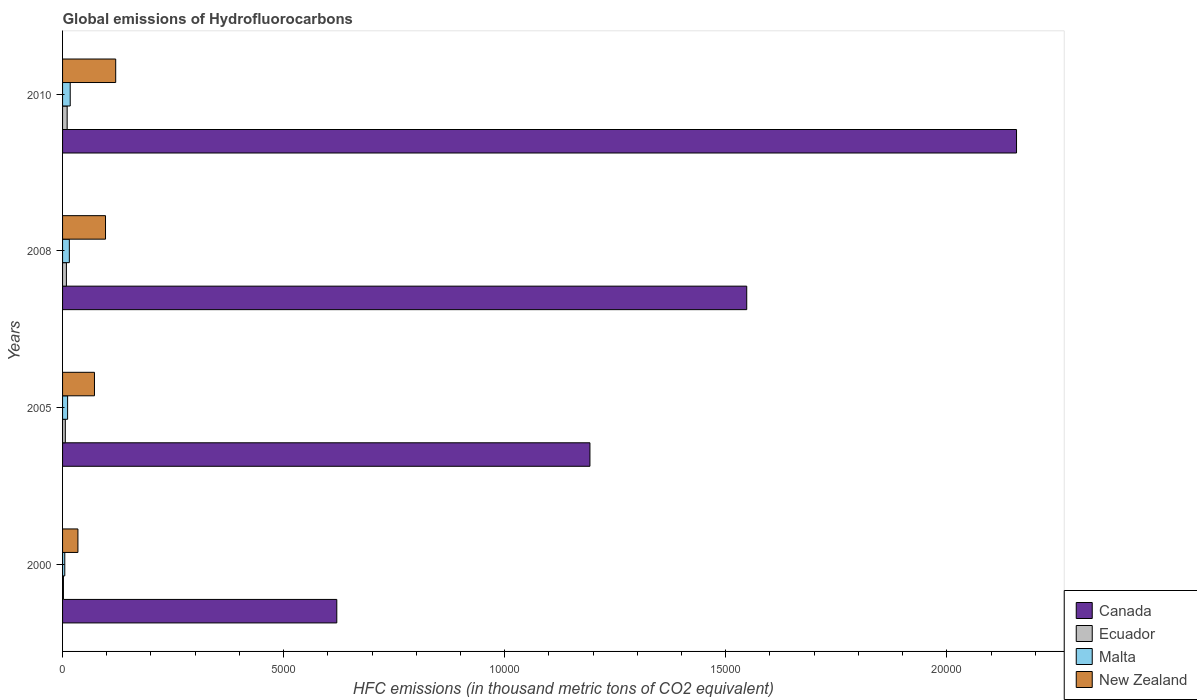How many groups of bars are there?
Offer a very short reply. 4. Are the number of bars on each tick of the Y-axis equal?
Your answer should be compact. Yes. How many bars are there on the 3rd tick from the top?
Ensure brevity in your answer.  4. What is the label of the 2nd group of bars from the top?
Ensure brevity in your answer.  2008. In how many cases, is the number of bars for a given year not equal to the number of legend labels?
Provide a succinct answer. 0. Across all years, what is the maximum global emissions of Hydrofluorocarbons in Ecuador?
Your response must be concise. 104. Across all years, what is the minimum global emissions of Hydrofluorocarbons in Malta?
Your answer should be very brief. 50. In which year was the global emissions of Hydrofluorocarbons in Canada maximum?
Make the answer very short. 2010. In which year was the global emissions of Hydrofluorocarbons in New Zealand minimum?
Provide a succinct answer. 2000. What is the total global emissions of Hydrofluorocarbons in Malta in the graph?
Your response must be concise. 490.4. What is the difference between the global emissions of Hydrofluorocarbons in Malta in 2000 and that in 2005?
Offer a very short reply. -64.2. What is the difference between the global emissions of Hydrofluorocarbons in Ecuador in 2010 and the global emissions of Hydrofluorocarbons in New Zealand in 2000?
Offer a very short reply. -243.3. What is the average global emissions of Hydrofluorocarbons in Malta per year?
Provide a succinct answer. 122.6. In the year 2000, what is the difference between the global emissions of Hydrofluorocarbons in Ecuador and global emissions of Hydrofluorocarbons in New Zealand?
Give a very brief answer. -327.6. In how many years, is the global emissions of Hydrofluorocarbons in New Zealand greater than 20000 thousand metric tons?
Your answer should be compact. 0. What is the ratio of the global emissions of Hydrofluorocarbons in New Zealand in 2005 to that in 2010?
Make the answer very short. 0.6. What is the difference between the highest and the second highest global emissions of Hydrofluorocarbons in New Zealand?
Your answer should be compact. 230.6. What is the difference between the highest and the lowest global emissions of Hydrofluorocarbons in New Zealand?
Offer a terse response. 854.7. What does the 4th bar from the top in 2000 represents?
Your answer should be very brief. Canada. What does the 3rd bar from the bottom in 2010 represents?
Give a very brief answer. Malta. How many years are there in the graph?
Make the answer very short. 4. How many legend labels are there?
Your answer should be very brief. 4. How are the legend labels stacked?
Give a very brief answer. Vertical. What is the title of the graph?
Offer a very short reply. Global emissions of Hydrofluorocarbons. What is the label or title of the X-axis?
Your answer should be very brief. HFC emissions (in thousand metric tons of CO2 equivalent). What is the HFC emissions (in thousand metric tons of CO2 equivalent) of Canada in 2000?
Your answer should be compact. 6202.8. What is the HFC emissions (in thousand metric tons of CO2 equivalent) of Ecuador in 2000?
Provide a succinct answer. 19.7. What is the HFC emissions (in thousand metric tons of CO2 equivalent) of Malta in 2000?
Your response must be concise. 50. What is the HFC emissions (in thousand metric tons of CO2 equivalent) in New Zealand in 2000?
Ensure brevity in your answer.  347.3. What is the HFC emissions (in thousand metric tons of CO2 equivalent) of Canada in 2005?
Offer a very short reply. 1.19e+04. What is the HFC emissions (in thousand metric tons of CO2 equivalent) of Ecuador in 2005?
Offer a very short reply. 62.2. What is the HFC emissions (in thousand metric tons of CO2 equivalent) in Malta in 2005?
Ensure brevity in your answer.  114.2. What is the HFC emissions (in thousand metric tons of CO2 equivalent) of New Zealand in 2005?
Your answer should be compact. 721.7. What is the HFC emissions (in thousand metric tons of CO2 equivalent) of Canada in 2008?
Provide a succinct answer. 1.55e+04. What is the HFC emissions (in thousand metric tons of CO2 equivalent) in Ecuador in 2008?
Your answer should be very brief. 86.7. What is the HFC emissions (in thousand metric tons of CO2 equivalent) in Malta in 2008?
Your answer should be compact. 153.2. What is the HFC emissions (in thousand metric tons of CO2 equivalent) in New Zealand in 2008?
Your response must be concise. 971.4. What is the HFC emissions (in thousand metric tons of CO2 equivalent) in Canada in 2010?
Your response must be concise. 2.16e+04. What is the HFC emissions (in thousand metric tons of CO2 equivalent) of Ecuador in 2010?
Your response must be concise. 104. What is the HFC emissions (in thousand metric tons of CO2 equivalent) in Malta in 2010?
Your answer should be compact. 173. What is the HFC emissions (in thousand metric tons of CO2 equivalent) in New Zealand in 2010?
Provide a short and direct response. 1202. Across all years, what is the maximum HFC emissions (in thousand metric tons of CO2 equivalent) of Canada?
Keep it short and to the point. 2.16e+04. Across all years, what is the maximum HFC emissions (in thousand metric tons of CO2 equivalent) in Ecuador?
Give a very brief answer. 104. Across all years, what is the maximum HFC emissions (in thousand metric tons of CO2 equivalent) of Malta?
Make the answer very short. 173. Across all years, what is the maximum HFC emissions (in thousand metric tons of CO2 equivalent) of New Zealand?
Give a very brief answer. 1202. Across all years, what is the minimum HFC emissions (in thousand metric tons of CO2 equivalent) of Canada?
Offer a terse response. 6202.8. Across all years, what is the minimum HFC emissions (in thousand metric tons of CO2 equivalent) in Ecuador?
Offer a very short reply. 19.7. Across all years, what is the minimum HFC emissions (in thousand metric tons of CO2 equivalent) of New Zealand?
Your response must be concise. 347.3. What is the total HFC emissions (in thousand metric tons of CO2 equivalent) of Canada in the graph?
Your answer should be very brief. 5.52e+04. What is the total HFC emissions (in thousand metric tons of CO2 equivalent) of Ecuador in the graph?
Ensure brevity in your answer.  272.6. What is the total HFC emissions (in thousand metric tons of CO2 equivalent) of Malta in the graph?
Provide a short and direct response. 490.4. What is the total HFC emissions (in thousand metric tons of CO2 equivalent) in New Zealand in the graph?
Your response must be concise. 3242.4. What is the difference between the HFC emissions (in thousand metric tons of CO2 equivalent) in Canada in 2000 and that in 2005?
Offer a very short reply. -5725.6. What is the difference between the HFC emissions (in thousand metric tons of CO2 equivalent) of Ecuador in 2000 and that in 2005?
Provide a short and direct response. -42.5. What is the difference between the HFC emissions (in thousand metric tons of CO2 equivalent) of Malta in 2000 and that in 2005?
Offer a terse response. -64.2. What is the difference between the HFC emissions (in thousand metric tons of CO2 equivalent) in New Zealand in 2000 and that in 2005?
Your answer should be very brief. -374.4. What is the difference between the HFC emissions (in thousand metric tons of CO2 equivalent) of Canada in 2000 and that in 2008?
Offer a terse response. -9272. What is the difference between the HFC emissions (in thousand metric tons of CO2 equivalent) in Ecuador in 2000 and that in 2008?
Provide a succinct answer. -67. What is the difference between the HFC emissions (in thousand metric tons of CO2 equivalent) in Malta in 2000 and that in 2008?
Give a very brief answer. -103.2. What is the difference between the HFC emissions (in thousand metric tons of CO2 equivalent) in New Zealand in 2000 and that in 2008?
Give a very brief answer. -624.1. What is the difference between the HFC emissions (in thousand metric tons of CO2 equivalent) in Canada in 2000 and that in 2010?
Make the answer very short. -1.54e+04. What is the difference between the HFC emissions (in thousand metric tons of CO2 equivalent) in Ecuador in 2000 and that in 2010?
Offer a terse response. -84.3. What is the difference between the HFC emissions (in thousand metric tons of CO2 equivalent) of Malta in 2000 and that in 2010?
Give a very brief answer. -123. What is the difference between the HFC emissions (in thousand metric tons of CO2 equivalent) in New Zealand in 2000 and that in 2010?
Make the answer very short. -854.7. What is the difference between the HFC emissions (in thousand metric tons of CO2 equivalent) of Canada in 2005 and that in 2008?
Give a very brief answer. -3546.4. What is the difference between the HFC emissions (in thousand metric tons of CO2 equivalent) in Ecuador in 2005 and that in 2008?
Give a very brief answer. -24.5. What is the difference between the HFC emissions (in thousand metric tons of CO2 equivalent) of Malta in 2005 and that in 2008?
Ensure brevity in your answer.  -39. What is the difference between the HFC emissions (in thousand metric tons of CO2 equivalent) in New Zealand in 2005 and that in 2008?
Your response must be concise. -249.7. What is the difference between the HFC emissions (in thousand metric tons of CO2 equivalent) in Canada in 2005 and that in 2010?
Offer a terse response. -9648.6. What is the difference between the HFC emissions (in thousand metric tons of CO2 equivalent) in Ecuador in 2005 and that in 2010?
Provide a succinct answer. -41.8. What is the difference between the HFC emissions (in thousand metric tons of CO2 equivalent) in Malta in 2005 and that in 2010?
Ensure brevity in your answer.  -58.8. What is the difference between the HFC emissions (in thousand metric tons of CO2 equivalent) of New Zealand in 2005 and that in 2010?
Give a very brief answer. -480.3. What is the difference between the HFC emissions (in thousand metric tons of CO2 equivalent) of Canada in 2008 and that in 2010?
Your answer should be very brief. -6102.2. What is the difference between the HFC emissions (in thousand metric tons of CO2 equivalent) in Ecuador in 2008 and that in 2010?
Make the answer very short. -17.3. What is the difference between the HFC emissions (in thousand metric tons of CO2 equivalent) of Malta in 2008 and that in 2010?
Offer a very short reply. -19.8. What is the difference between the HFC emissions (in thousand metric tons of CO2 equivalent) in New Zealand in 2008 and that in 2010?
Ensure brevity in your answer.  -230.6. What is the difference between the HFC emissions (in thousand metric tons of CO2 equivalent) in Canada in 2000 and the HFC emissions (in thousand metric tons of CO2 equivalent) in Ecuador in 2005?
Keep it short and to the point. 6140.6. What is the difference between the HFC emissions (in thousand metric tons of CO2 equivalent) of Canada in 2000 and the HFC emissions (in thousand metric tons of CO2 equivalent) of Malta in 2005?
Offer a very short reply. 6088.6. What is the difference between the HFC emissions (in thousand metric tons of CO2 equivalent) of Canada in 2000 and the HFC emissions (in thousand metric tons of CO2 equivalent) of New Zealand in 2005?
Your response must be concise. 5481.1. What is the difference between the HFC emissions (in thousand metric tons of CO2 equivalent) in Ecuador in 2000 and the HFC emissions (in thousand metric tons of CO2 equivalent) in Malta in 2005?
Give a very brief answer. -94.5. What is the difference between the HFC emissions (in thousand metric tons of CO2 equivalent) of Ecuador in 2000 and the HFC emissions (in thousand metric tons of CO2 equivalent) of New Zealand in 2005?
Keep it short and to the point. -702. What is the difference between the HFC emissions (in thousand metric tons of CO2 equivalent) of Malta in 2000 and the HFC emissions (in thousand metric tons of CO2 equivalent) of New Zealand in 2005?
Offer a very short reply. -671.7. What is the difference between the HFC emissions (in thousand metric tons of CO2 equivalent) of Canada in 2000 and the HFC emissions (in thousand metric tons of CO2 equivalent) of Ecuador in 2008?
Ensure brevity in your answer.  6116.1. What is the difference between the HFC emissions (in thousand metric tons of CO2 equivalent) of Canada in 2000 and the HFC emissions (in thousand metric tons of CO2 equivalent) of Malta in 2008?
Ensure brevity in your answer.  6049.6. What is the difference between the HFC emissions (in thousand metric tons of CO2 equivalent) of Canada in 2000 and the HFC emissions (in thousand metric tons of CO2 equivalent) of New Zealand in 2008?
Ensure brevity in your answer.  5231.4. What is the difference between the HFC emissions (in thousand metric tons of CO2 equivalent) of Ecuador in 2000 and the HFC emissions (in thousand metric tons of CO2 equivalent) of Malta in 2008?
Ensure brevity in your answer.  -133.5. What is the difference between the HFC emissions (in thousand metric tons of CO2 equivalent) of Ecuador in 2000 and the HFC emissions (in thousand metric tons of CO2 equivalent) of New Zealand in 2008?
Provide a short and direct response. -951.7. What is the difference between the HFC emissions (in thousand metric tons of CO2 equivalent) in Malta in 2000 and the HFC emissions (in thousand metric tons of CO2 equivalent) in New Zealand in 2008?
Ensure brevity in your answer.  -921.4. What is the difference between the HFC emissions (in thousand metric tons of CO2 equivalent) of Canada in 2000 and the HFC emissions (in thousand metric tons of CO2 equivalent) of Ecuador in 2010?
Give a very brief answer. 6098.8. What is the difference between the HFC emissions (in thousand metric tons of CO2 equivalent) of Canada in 2000 and the HFC emissions (in thousand metric tons of CO2 equivalent) of Malta in 2010?
Offer a terse response. 6029.8. What is the difference between the HFC emissions (in thousand metric tons of CO2 equivalent) in Canada in 2000 and the HFC emissions (in thousand metric tons of CO2 equivalent) in New Zealand in 2010?
Keep it short and to the point. 5000.8. What is the difference between the HFC emissions (in thousand metric tons of CO2 equivalent) of Ecuador in 2000 and the HFC emissions (in thousand metric tons of CO2 equivalent) of Malta in 2010?
Give a very brief answer. -153.3. What is the difference between the HFC emissions (in thousand metric tons of CO2 equivalent) in Ecuador in 2000 and the HFC emissions (in thousand metric tons of CO2 equivalent) in New Zealand in 2010?
Offer a very short reply. -1182.3. What is the difference between the HFC emissions (in thousand metric tons of CO2 equivalent) in Malta in 2000 and the HFC emissions (in thousand metric tons of CO2 equivalent) in New Zealand in 2010?
Keep it short and to the point. -1152. What is the difference between the HFC emissions (in thousand metric tons of CO2 equivalent) of Canada in 2005 and the HFC emissions (in thousand metric tons of CO2 equivalent) of Ecuador in 2008?
Provide a succinct answer. 1.18e+04. What is the difference between the HFC emissions (in thousand metric tons of CO2 equivalent) of Canada in 2005 and the HFC emissions (in thousand metric tons of CO2 equivalent) of Malta in 2008?
Offer a very short reply. 1.18e+04. What is the difference between the HFC emissions (in thousand metric tons of CO2 equivalent) of Canada in 2005 and the HFC emissions (in thousand metric tons of CO2 equivalent) of New Zealand in 2008?
Provide a succinct answer. 1.10e+04. What is the difference between the HFC emissions (in thousand metric tons of CO2 equivalent) of Ecuador in 2005 and the HFC emissions (in thousand metric tons of CO2 equivalent) of Malta in 2008?
Your answer should be compact. -91. What is the difference between the HFC emissions (in thousand metric tons of CO2 equivalent) of Ecuador in 2005 and the HFC emissions (in thousand metric tons of CO2 equivalent) of New Zealand in 2008?
Keep it short and to the point. -909.2. What is the difference between the HFC emissions (in thousand metric tons of CO2 equivalent) of Malta in 2005 and the HFC emissions (in thousand metric tons of CO2 equivalent) of New Zealand in 2008?
Keep it short and to the point. -857.2. What is the difference between the HFC emissions (in thousand metric tons of CO2 equivalent) of Canada in 2005 and the HFC emissions (in thousand metric tons of CO2 equivalent) of Ecuador in 2010?
Keep it short and to the point. 1.18e+04. What is the difference between the HFC emissions (in thousand metric tons of CO2 equivalent) of Canada in 2005 and the HFC emissions (in thousand metric tons of CO2 equivalent) of Malta in 2010?
Provide a short and direct response. 1.18e+04. What is the difference between the HFC emissions (in thousand metric tons of CO2 equivalent) in Canada in 2005 and the HFC emissions (in thousand metric tons of CO2 equivalent) in New Zealand in 2010?
Keep it short and to the point. 1.07e+04. What is the difference between the HFC emissions (in thousand metric tons of CO2 equivalent) in Ecuador in 2005 and the HFC emissions (in thousand metric tons of CO2 equivalent) in Malta in 2010?
Keep it short and to the point. -110.8. What is the difference between the HFC emissions (in thousand metric tons of CO2 equivalent) of Ecuador in 2005 and the HFC emissions (in thousand metric tons of CO2 equivalent) of New Zealand in 2010?
Give a very brief answer. -1139.8. What is the difference between the HFC emissions (in thousand metric tons of CO2 equivalent) of Malta in 2005 and the HFC emissions (in thousand metric tons of CO2 equivalent) of New Zealand in 2010?
Ensure brevity in your answer.  -1087.8. What is the difference between the HFC emissions (in thousand metric tons of CO2 equivalent) of Canada in 2008 and the HFC emissions (in thousand metric tons of CO2 equivalent) of Ecuador in 2010?
Keep it short and to the point. 1.54e+04. What is the difference between the HFC emissions (in thousand metric tons of CO2 equivalent) of Canada in 2008 and the HFC emissions (in thousand metric tons of CO2 equivalent) of Malta in 2010?
Offer a very short reply. 1.53e+04. What is the difference between the HFC emissions (in thousand metric tons of CO2 equivalent) of Canada in 2008 and the HFC emissions (in thousand metric tons of CO2 equivalent) of New Zealand in 2010?
Keep it short and to the point. 1.43e+04. What is the difference between the HFC emissions (in thousand metric tons of CO2 equivalent) of Ecuador in 2008 and the HFC emissions (in thousand metric tons of CO2 equivalent) of Malta in 2010?
Offer a very short reply. -86.3. What is the difference between the HFC emissions (in thousand metric tons of CO2 equivalent) of Ecuador in 2008 and the HFC emissions (in thousand metric tons of CO2 equivalent) of New Zealand in 2010?
Your answer should be very brief. -1115.3. What is the difference between the HFC emissions (in thousand metric tons of CO2 equivalent) of Malta in 2008 and the HFC emissions (in thousand metric tons of CO2 equivalent) of New Zealand in 2010?
Keep it short and to the point. -1048.8. What is the average HFC emissions (in thousand metric tons of CO2 equivalent) in Canada per year?
Your answer should be very brief. 1.38e+04. What is the average HFC emissions (in thousand metric tons of CO2 equivalent) of Ecuador per year?
Your response must be concise. 68.15. What is the average HFC emissions (in thousand metric tons of CO2 equivalent) of Malta per year?
Ensure brevity in your answer.  122.6. What is the average HFC emissions (in thousand metric tons of CO2 equivalent) in New Zealand per year?
Ensure brevity in your answer.  810.6. In the year 2000, what is the difference between the HFC emissions (in thousand metric tons of CO2 equivalent) in Canada and HFC emissions (in thousand metric tons of CO2 equivalent) in Ecuador?
Your response must be concise. 6183.1. In the year 2000, what is the difference between the HFC emissions (in thousand metric tons of CO2 equivalent) of Canada and HFC emissions (in thousand metric tons of CO2 equivalent) of Malta?
Offer a terse response. 6152.8. In the year 2000, what is the difference between the HFC emissions (in thousand metric tons of CO2 equivalent) in Canada and HFC emissions (in thousand metric tons of CO2 equivalent) in New Zealand?
Make the answer very short. 5855.5. In the year 2000, what is the difference between the HFC emissions (in thousand metric tons of CO2 equivalent) of Ecuador and HFC emissions (in thousand metric tons of CO2 equivalent) of Malta?
Offer a terse response. -30.3. In the year 2000, what is the difference between the HFC emissions (in thousand metric tons of CO2 equivalent) in Ecuador and HFC emissions (in thousand metric tons of CO2 equivalent) in New Zealand?
Your response must be concise. -327.6. In the year 2000, what is the difference between the HFC emissions (in thousand metric tons of CO2 equivalent) in Malta and HFC emissions (in thousand metric tons of CO2 equivalent) in New Zealand?
Provide a short and direct response. -297.3. In the year 2005, what is the difference between the HFC emissions (in thousand metric tons of CO2 equivalent) of Canada and HFC emissions (in thousand metric tons of CO2 equivalent) of Ecuador?
Give a very brief answer. 1.19e+04. In the year 2005, what is the difference between the HFC emissions (in thousand metric tons of CO2 equivalent) in Canada and HFC emissions (in thousand metric tons of CO2 equivalent) in Malta?
Your response must be concise. 1.18e+04. In the year 2005, what is the difference between the HFC emissions (in thousand metric tons of CO2 equivalent) in Canada and HFC emissions (in thousand metric tons of CO2 equivalent) in New Zealand?
Ensure brevity in your answer.  1.12e+04. In the year 2005, what is the difference between the HFC emissions (in thousand metric tons of CO2 equivalent) of Ecuador and HFC emissions (in thousand metric tons of CO2 equivalent) of Malta?
Provide a short and direct response. -52. In the year 2005, what is the difference between the HFC emissions (in thousand metric tons of CO2 equivalent) in Ecuador and HFC emissions (in thousand metric tons of CO2 equivalent) in New Zealand?
Offer a terse response. -659.5. In the year 2005, what is the difference between the HFC emissions (in thousand metric tons of CO2 equivalent) in Malta and HFC emissions (in thousand metric tons of CO2 equivalent) in New Zealand?
Your response must be concise. -607.5. In the year 2008, what is the difference between the HFC emissions (in thousand metric tons of CO2 equivalent) in Canada and HFC emissions (in thousand metric tons of CO2 equivalent) in Ecuador?
Keep it short and to the point. 1.54e+04. In the year 2008, what is the difference between the HFC emissions (in thousand metric tons of CO2 equivalent) of Canada and HFC emissions (in thousand metric tons of CO2 equivalent) of Malta?
Your response must be concise. 1.53e+04. In the year 2008, what is the difference between the HFC emissions (in thousand metric tons of CO2 equivalent) in Canada and HFC emissions (in thousand metric tons of CO2 equivalent) in New Zealand?
Provide a succinct answer. 1.45e+04. In the year 2008, what is the difference between the HFC emissions (in thousand metric tons of CO2 equivalent) in Ecuador and HFC emissions (in thousand metric tons of CO2 equivalent) in Malta?
Your answer should be compact. -66.5. In the year 2008, what is the difference between the HFC emissions (in thousand metric tons of CO2 equivalent) in Ecuador and HFC emissions (in thousand metric tons of CO2 equivalent) in New Zealand?
Your answer should be very brief. -884.7. In the year 2008, what is the difference between the HFC emissions (in thousand metric tons of CO2 equivalent) in Malta and HFC emissions (in thousand metric tons of CO2 equivalent) in New Zealand?
Provide a succinct answer. -818.2. In the year 2010, what is the difference between the HFC emissions (in thousand metric tons of CO2 equivalent) of Canada and HFC emissions (in thousand metric tons of CO2 equivalent) of Ecuador?
Provide a succinct answer. 2.15e+04. In the year 2010, what is the difference between the HFC emissions (in thousand metric tons of CO2 equivalent) in Canada and HFC emissions (in thousand metric tons of CO2 equivalent) in Malta?
Ensure brevity in your answer.  2.14e+04. In the year 2010, what is the difference between the HFC emissions (in thousand metric tons of CO2 equivalent) in Canada and HFC emissions (in thousand metric tons of CO2 equivalent) in New Zealand?
Make the answer very short. 2.04e+04. In the year 2010, what is the difference between the HFC emissions (in thousand metric tons of CO2 equivalent) in Ecuador and HFC emissions (in thousand metric tons of CO2 equivalent) in Malta?
Ensure brevity in your answer.  -69. In the year 2010, what is the difference between the HFC emissions (in thousand metric tons of CO2 equivalent) of Ecuador and HFC emissions (in thousand metric tons of CO2 equivalent) of New Zealand?
Your response must be concise. -1098. In the year 2010, what is the difference between the HFC emissions (in thousand metric tons of CO2 equivalent) in Malta and HFC emissions (in thousand metric tons of CO2 equivalent) in New Zealand?
Your response must be concise. -1029. What is the ratio of the HFC emissions (in thousand metric tons of CO2 equivalent) of Canada in 2000 to that in 2005?
Your response must be concise. 0.52. What is the ratio of the HFC emissions (in thousand metric tons of CO2 equivalent) of Ecuador in 2000 to that in 2005?
Offer a very short reply. 0.32. What is the ratio of the HFC emissions (in thousand metric tons of CO2 equivalent) in Malta in 2000 to that in 2005?
Your answer should be very brief. 0.44. What is the ratio of the HFC emissions (in thousand metric tons of CO2 equivalent) of New Zealand in 2000 to that in 2005?
Offer a very short reply. 0.48. What is the ratio of the HFC emissions (in thousand metric tons of CO2 equivalent) in Canada in 2000 to that in 2008?
Your response must be concise. 0.4. What is the ratio of the HFC emissions (in thousand metric tons of CO2 equivalent) of Ecuador in 2000 to that in 2008?
Make the answer very short. 0.23. What is the ratio of the HFC emissions (in thousand metric tons of CO2 equivalent) in Malta in 2000 to that in 2008?
Your response must be concise. 0.33. What is the ratio of the HFC emissions (in thousand metric tons of CO2 equivalent) of New Zealand in 2000 to that in 2008?
Give a very brief answer. 0.36. What is the ratio of the HFC emissions (in thousand metric tons of CO2 equivalent) in Canada in 2000 to that in 2010?
Keep it short and to the point. 0.29. What is the ratio of the HFC emissions (in thousand metric tons of CO2 equivalent) in Ecuador in 2000 to that in 2010?
Provide a succinct answer. 0.19. What is the ratio of the HFC emissions (in thousand metric tons of CO2 equivalent) in Malta in 2000 to that in 2010?
Keep it short and to the point. 0.29. What is the ratio of the HFC emissions (in thousand metric tons of CO2 equivalent) of New Zealand in 2000 to that in 2010?
Provide a succinct answer. 0.29. What is the ratio of the HFC emissions (in thousand metric tons of CO2 equivalent) in Canada in 2005 to that in 2008?
Provide a short and direct response. 0.77. What is the ratio of the HFC emissions (in thousand metric tons of CO2 equivalent) of Ecuador in 2005 to that in 2008?
Provide a succinct answer. 0.72. What is the ratio of the HFC emissions (in thousand metric tons of CO2 equivalent) in Malta in 2005 to that in 2008?
Offer a terse response. 0.75. What is the ratio of the HFC emissions (in thousand metric tons of CO2 equivalent) of New Zealand in 2005 to that in 2008?
Make the answer very short. 0.74. What is the ratio of the HFC emissions (in thousand metric tons of CO2 equivalent) in Canada in 2005 to that in 2010?
Offer a terse response. 0.55. What is the ratio of the HFC emissions (in thousand metric tons of CO2 equivalent) of Ecuador in 2005 to that in 2010?
Keep it short and to the point. 0.6. What is the ratio of the HFC emissions (in thousand metric tons of CO2 equivalent) of Malta in 2005 to that in 2010?
Provide a short and direct response. 0.66. What is the ratio of the HFC emissions (in thousand metric tons of CO2 equivalent) of New Zealand in 2005 to that in 2010?
Offer a terse response. 0.6. What is the ratio of the HFC emissions (in thousand metric tons of CO2 equivalent) in Canada in 2008 to that in 2010?
Keep it short and to the point. 0.72. What is the ratio of the HFC emissions (in thousand metric tons of CO2 equivalent) in Ecuador in 2008 to that in 2010?
Provide a succinct answer. 0.83. What is the ratio of the HFC emissions (in thousand metric tons of CO2 equivalent) in Malta in 2008 to that in 2010?
Offer a terse response. 0.89. What is the ratio of the HFC emissions (in thousand metric tons of CO2 equivalent) in New Zealand in 2008 to that in 2010?
Ensure brevity in your answer.  0.81. What is the difference between the highest and the second highest HFC emissions (in thousand metric tons of CO2 equivalent) of Canada?
Provide a succinct answer. 6102.2. What is the difference between the highest and the second highest HFC emissions (in thousand metric tons of CO2 equivalent) of Ecuador?
Your answer should be compact. 17.3. What is the difference between the highest and the second highest HFC emissions (in thousand metric tons of CO2 equivalent) of Malta?
Provide a succinct answer. 19.8. What is the difference between the highest and the second highest HFC emissions (in thousand metric tons of CO2 equivalent) of New Zealand?
Make the answer very short. 230.6. What is the difference between the highest and the lowest HFC emissions (in thousand metric tons of CO2 equivalent) of Canada?
Keep it short and to the point. 1.54e+04. What is the difference between the highest and the lowest HFC emissions (in thousand metric tons of CO2 equivalent) of Ecuador?
Ensure brevity in your answer.  84.3. What is the difference between the highest and the lowest HFC emissions (in thousand metric tons of CO2 equivalent) in Malta?
Your answer should be very brief. 123. What is the difference between the highest and the lowest HFC emissions (in thousand metric tons of CO2 equivalent) of New Zealand?
Your answer should be compact. 854.7. 